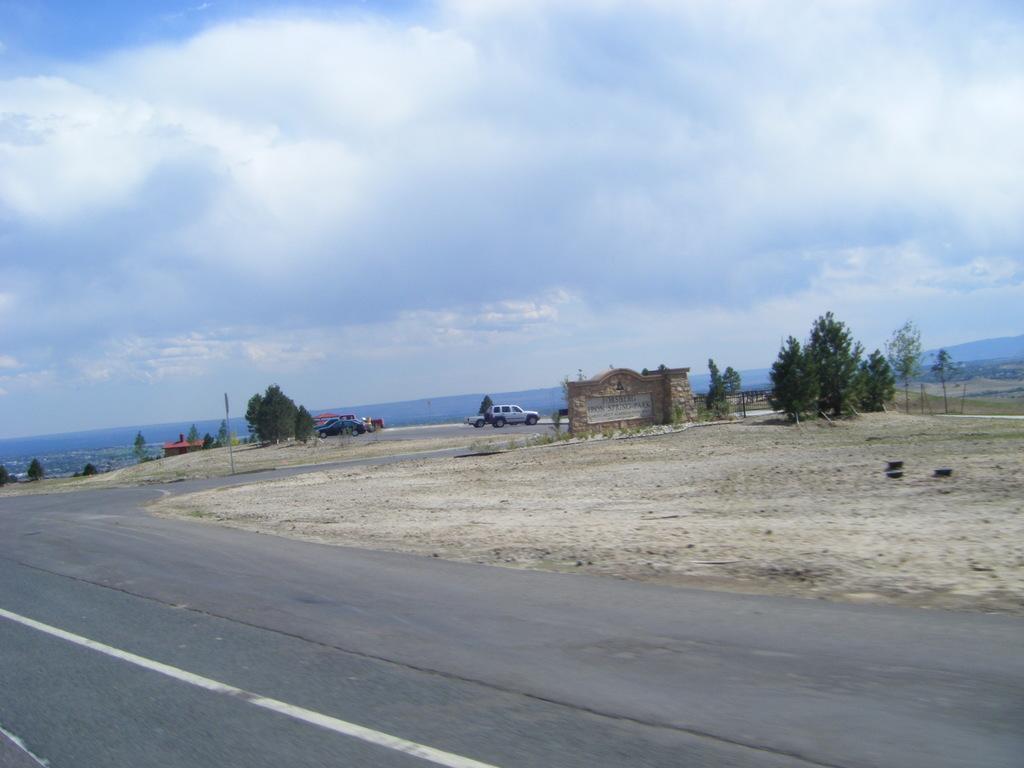Describe this image in one or two sentences. This image is clicked on the road. At the bottom, there is a road. In the front, we can see a memorial wall and cars parked on the ground. At the top, there are clouds in the sky. And we can see few trees. 